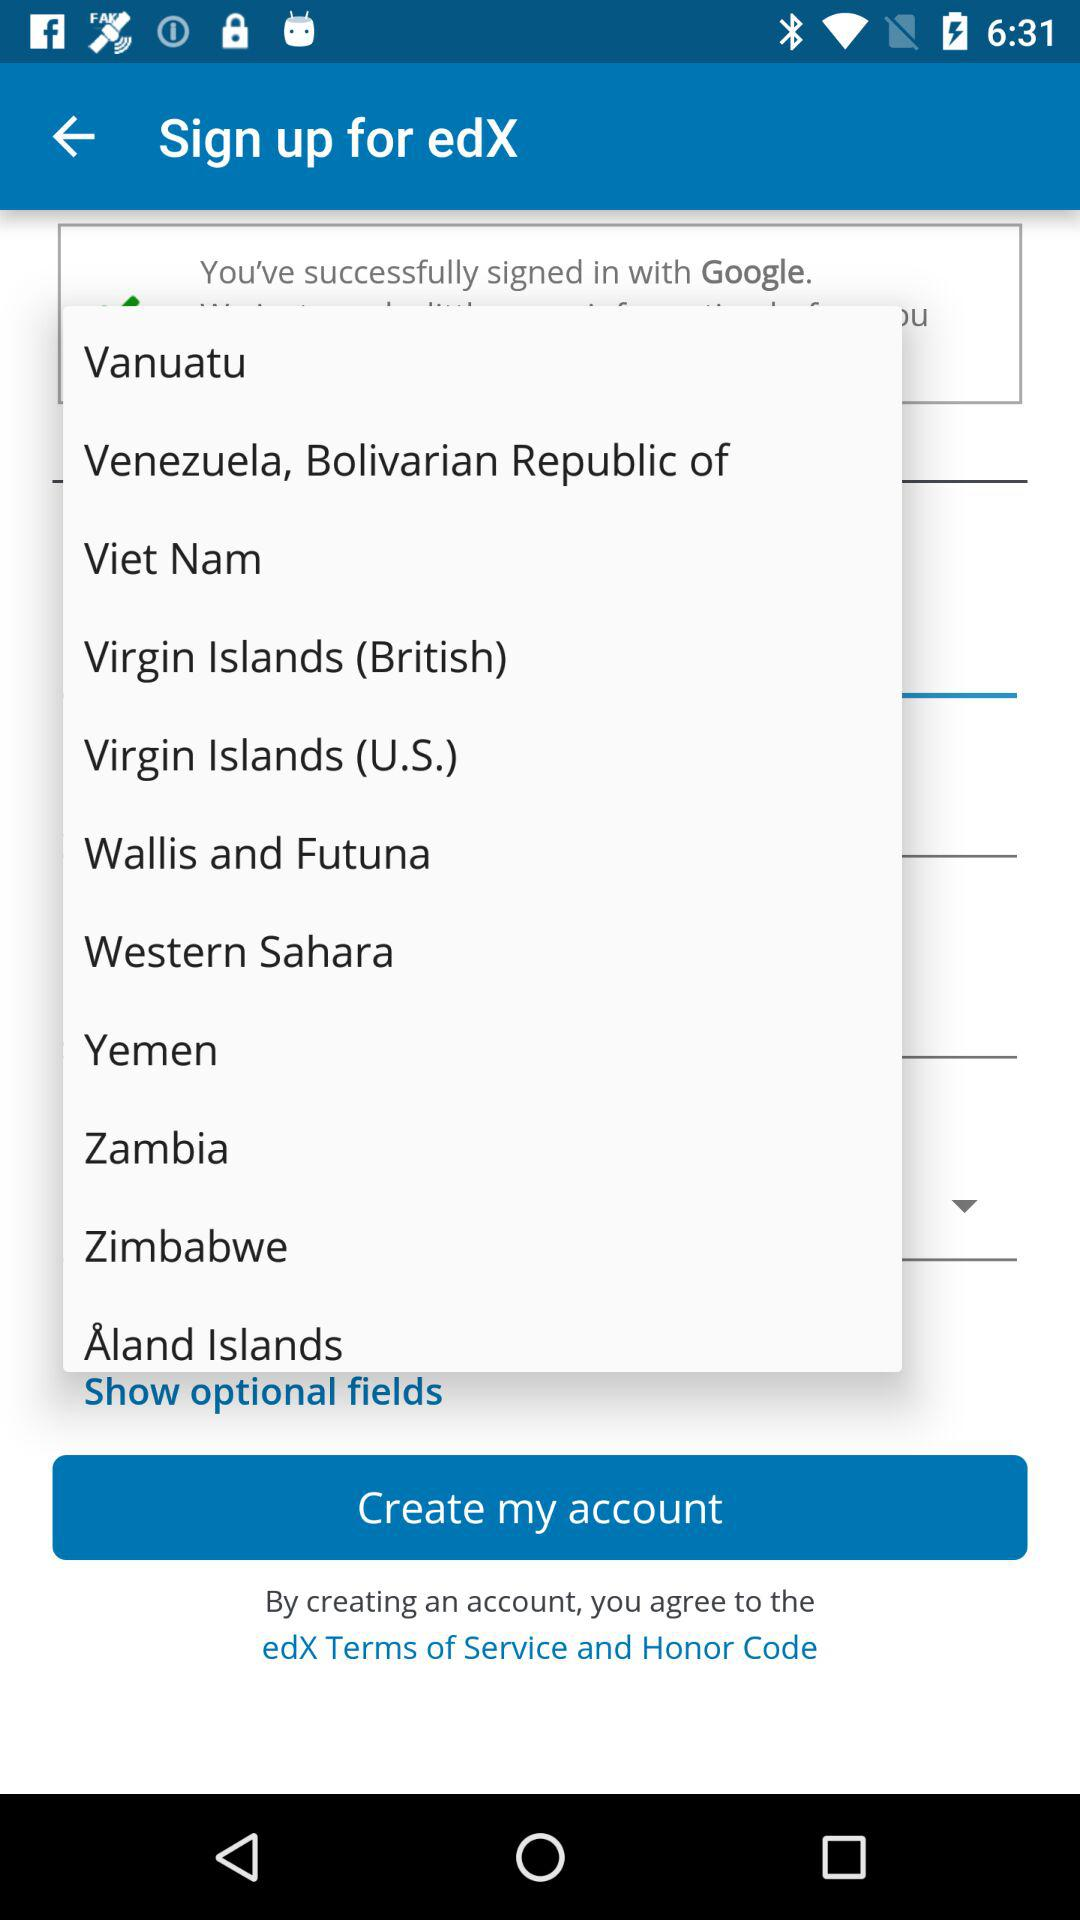Which application version is being used?
When the provided information is insufficient, respond with <no answer>. <no answer> 